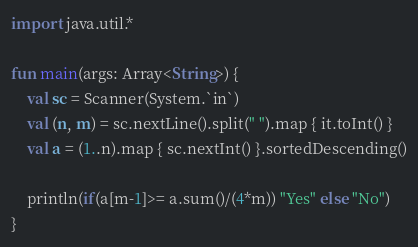<code> <loc_0><loc_0><loc_500><loc_500><_Kotlin_>import java.util.*

fun main(args: Array<String>) {
    val sc = Scanner(System.`in`)
    val (n, m) = sc.nextLine().split(" ").map { it.toInt() }
    val a = (1..n).map { sc.nextInt() }.sortedDescending()

    println(if(a[m-1]>= a.sum()/(4*m)) "Yes" else "No")
}</code> 